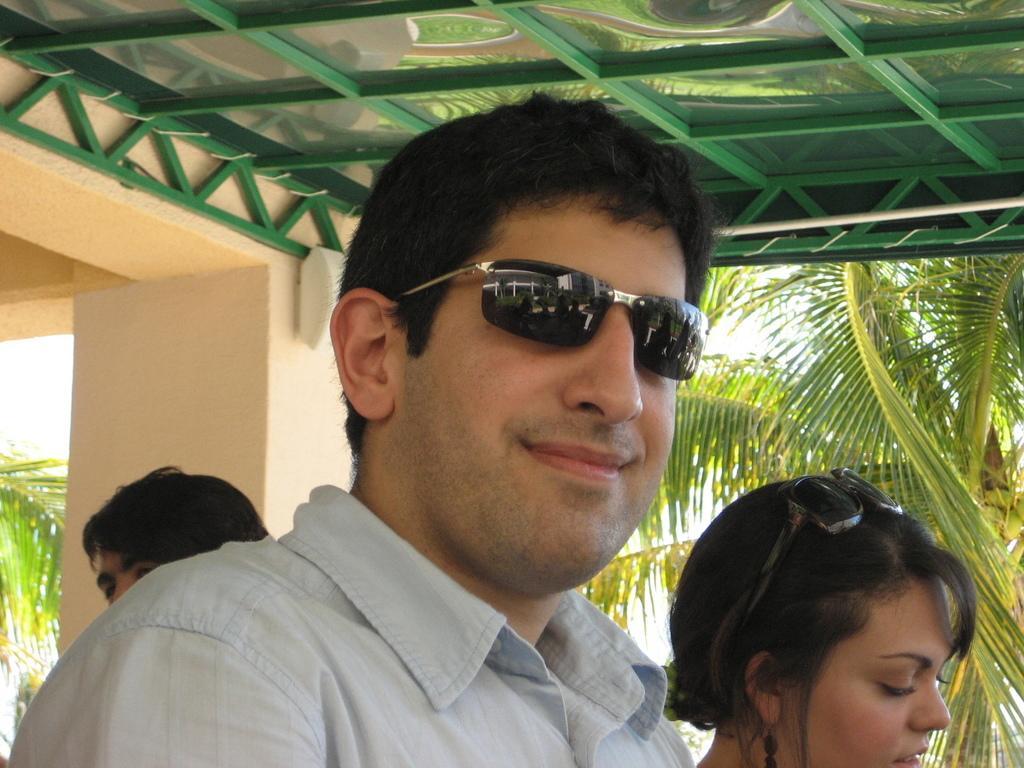Can you describe this image briefly? In this image there are few people. At the top of the image there is a ceiling. In the background there is a pillar of a building and trees. 